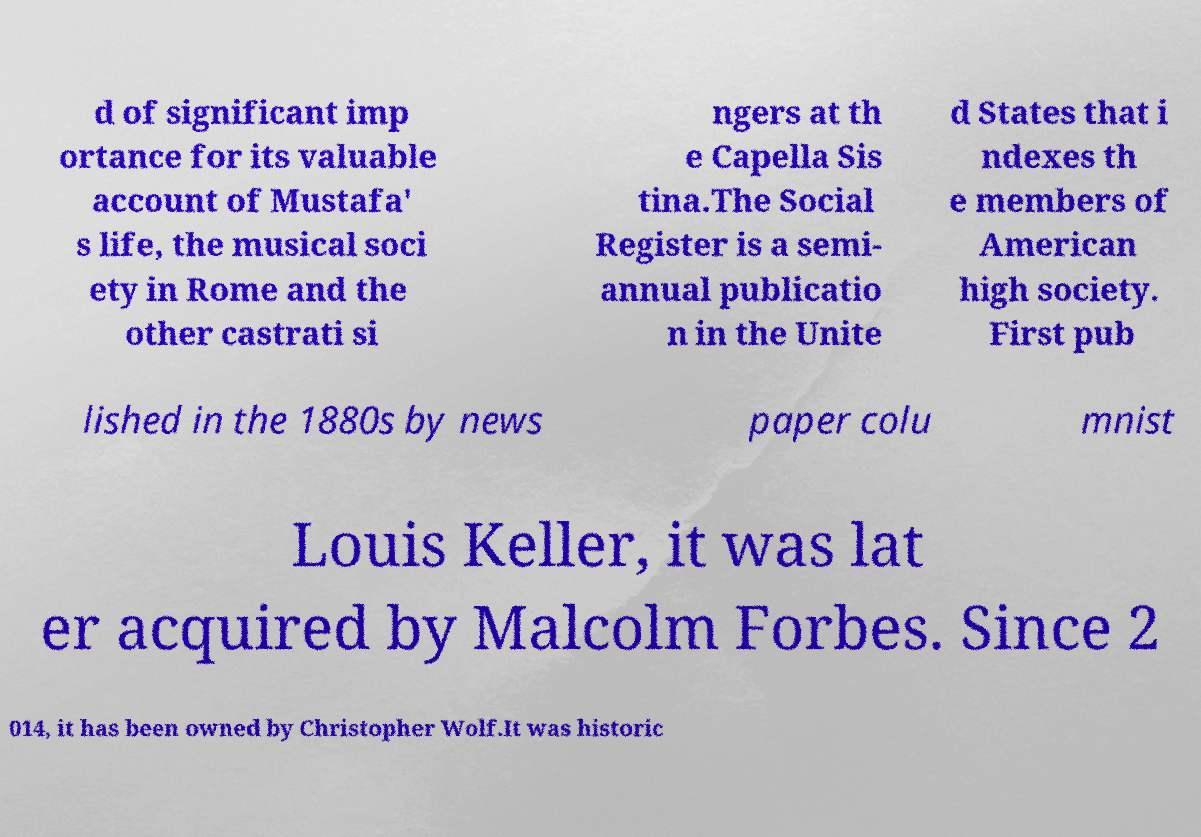Please identify and transcribe the text found in this image. d of significant imp ortance for its valuable account of Mustafa' s life, the musical soci ety in Rome and the other castrati si ngers at th e Capella Sis tina.The Social Register is a semi- annual publicatio n in the Unite d States that i ndexes th e members of American high society. First pub lished in the 1880s by news paper colu mnist Louis Keller, it was lat er acquired by Malcolm Forbes. Since 2 014, it has been owned by Christopher Wolf.It was historic 